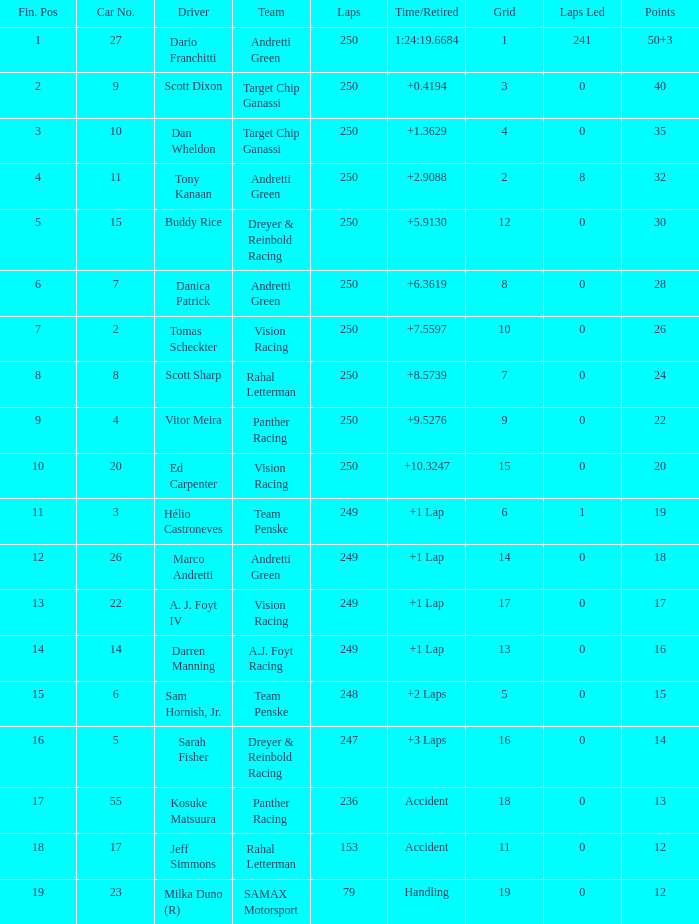Name the number of driver for fin pos of 19 1.0. 